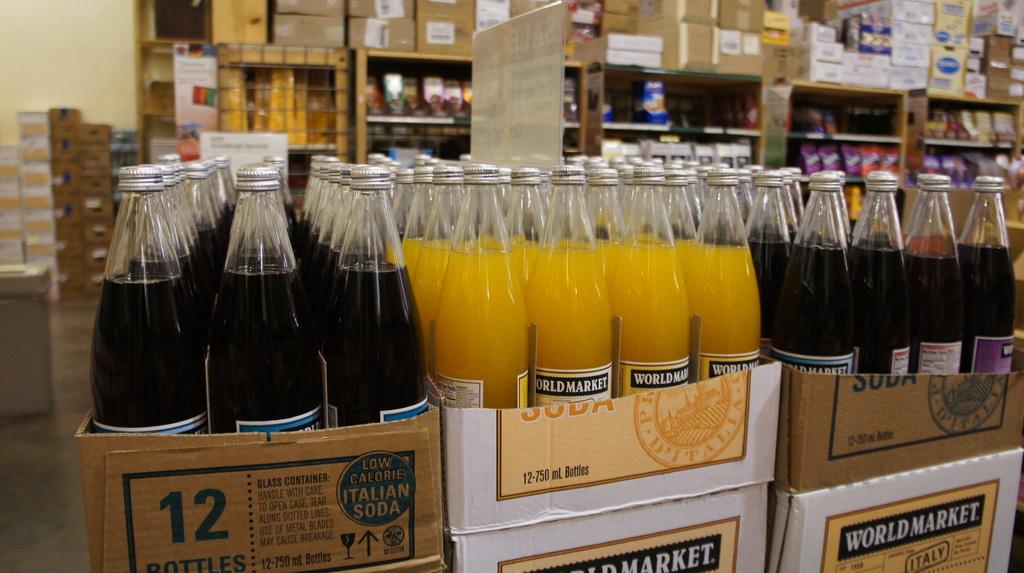How many bottles are in the left box?
Make the answer very short. 12. What market is mentioned on the box?
Ensure brevity in your answer.  World market. 